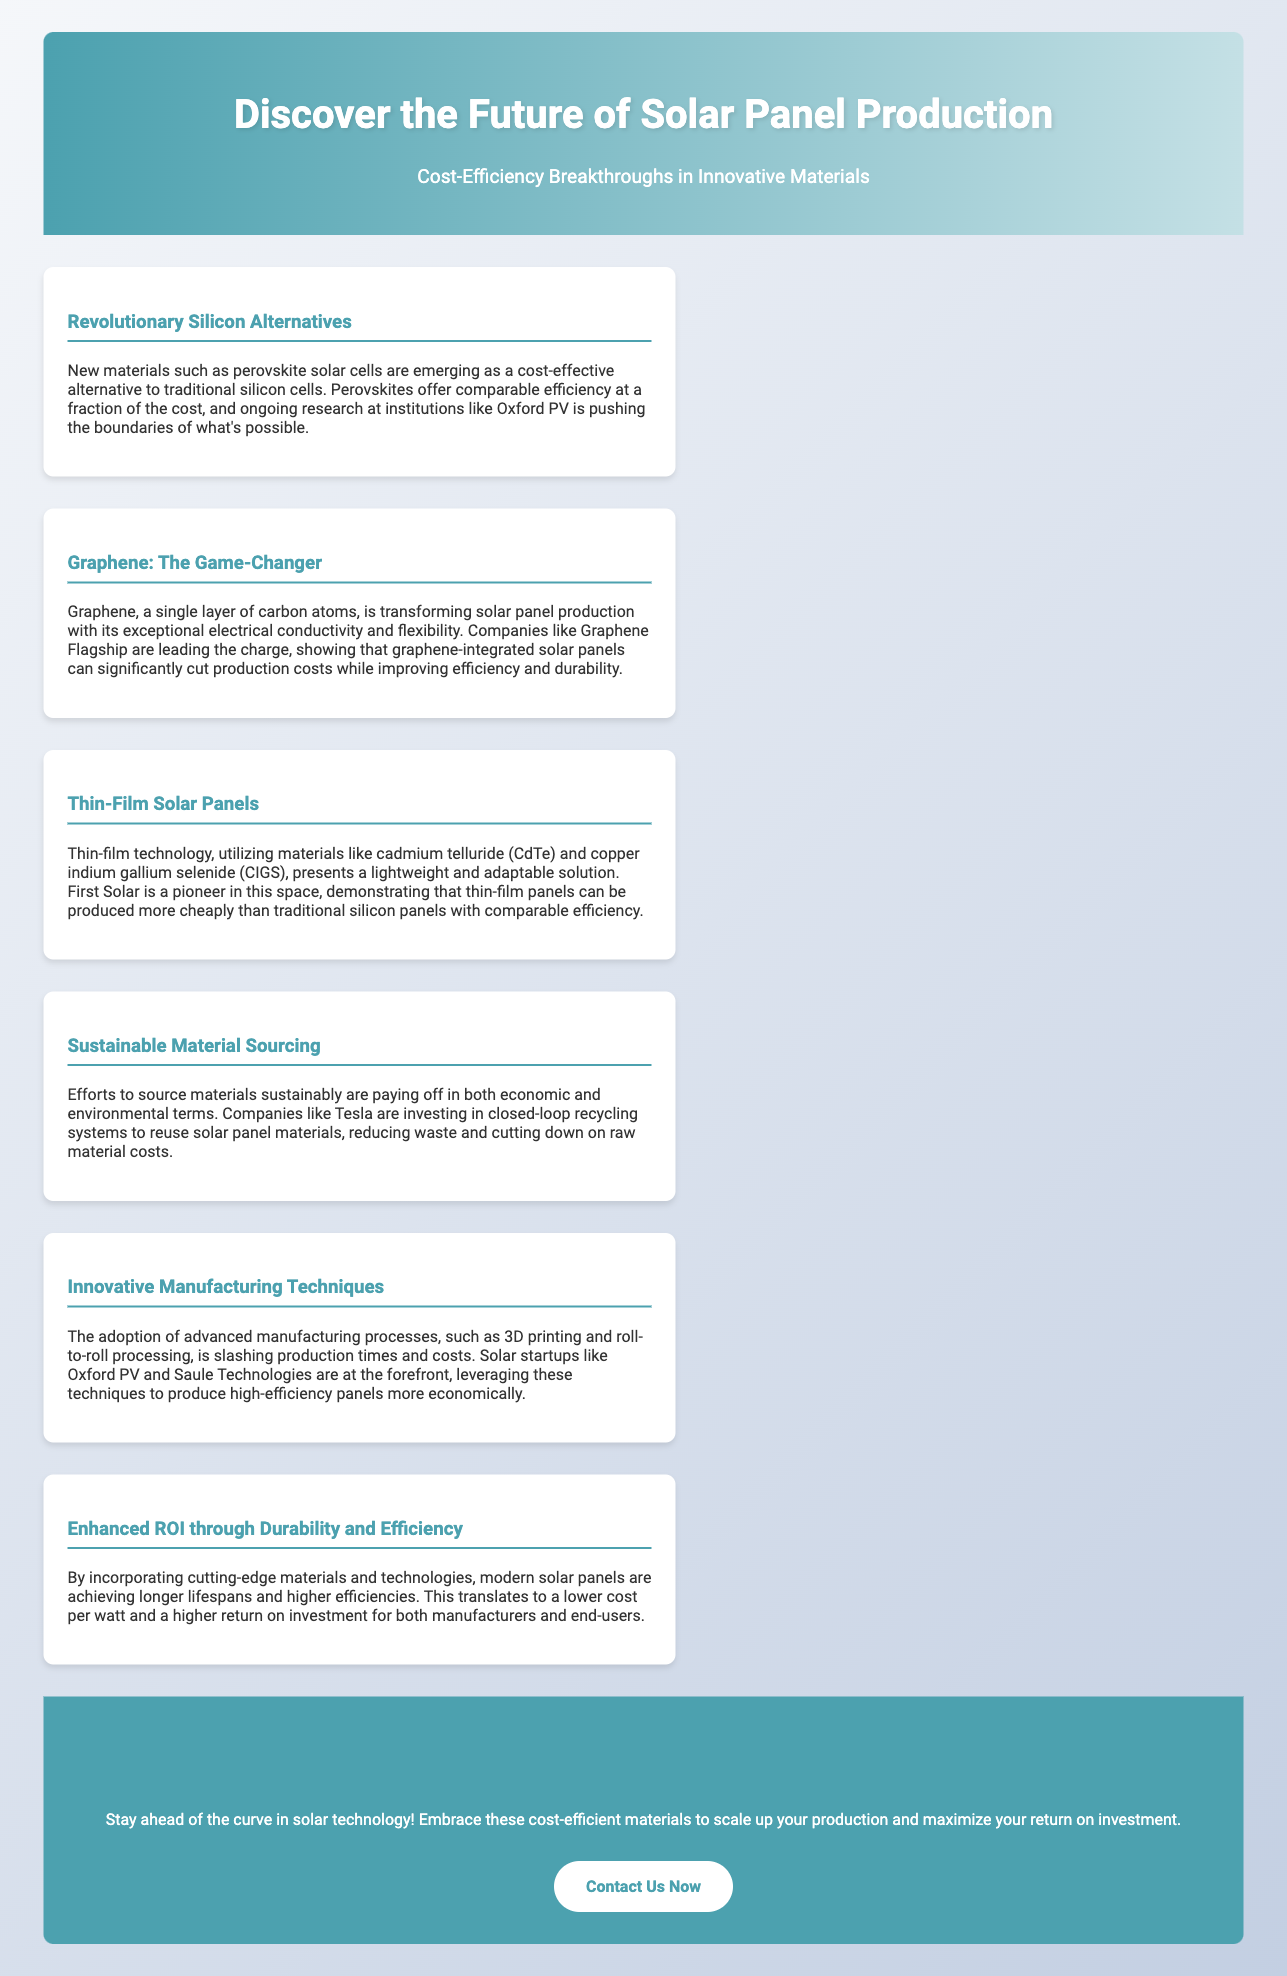What is the title of the advertisement? The title of the advertisement is found at the top of the document, which introduces the main topic of discussion.
Answer: Discover the Future of Solar Panel Production Who is mentioned as a leader in thin-film technology? First Solar is noted in the document for pioneering thin-film panel technologies.
Answer: First Solar What material does the document mention as being an alternative to traditional silicon cells? The advertisement discusses new materials that offer cost-effective alternatives to silicon, specifically highlighting perovskite cells.
Answer: Perovskite What is one of the benefits of using graphene in solar panels? The document explains the exceptional qualities of graphene that enhance solar panel production, leading to reduced costs and improved performance.
Answer: Exceptional electrical conductivity and flexibility Which advanced manufacturing processes are mentioned? The advertisement outlines advanced production techniques that are being adopted to streamline manufacturing processes in the solar industry.
Answer: 3D printing and roll-to-roll processing What are companies like Tesla investing in to reduce costs? The document highlights Tesla's efforts focused on environmental sustainability and economic efficiency through innovative practices.
Answer: Closed-loop recycling systems What overall benefit do modern solar panels provide? The advertisement emphasizes that modern solar panels, through innovative designs, lead to enhanced efficiency and durability resulting in better financial returns.
Answer: Enhanced ROI through Durability and Efficiency What action does the advertisement encourage at the end? The conclusion of the advertisement promotes taking specific actions to leverage the discussed innovations for improved business outcomes.
Answer: Scale Up Your Production Today 